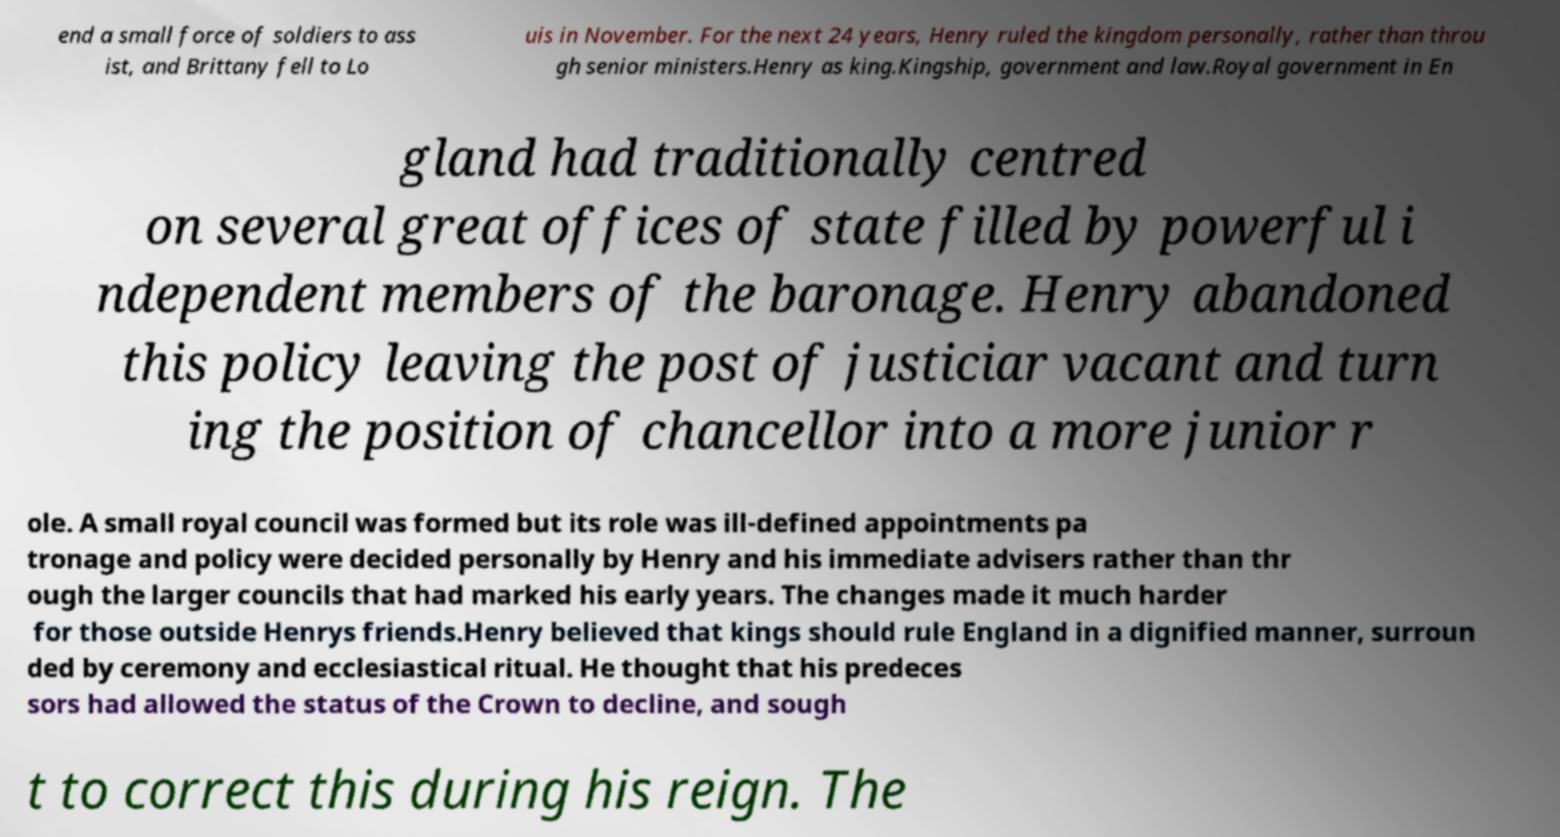Could you extract and type out the text from this image? end a small force of soldiers to ass ist, and Brittany fell to Lo uis in November. For the next 24 years, Henry ruled the kingdom personally, rather than throu gh senior ministers.Henry as king.Kingship, government and law.Royal government in En gland had traditionally centred on several great offices of state filled by powerful i ndependent members of the baronage. Henry abandoned this policy leaving the post of justiciar vacant and turn ing the position of chancellor into a more junior r ole. A small royal council was formed but its role was ill-defined appointments pa tronage and policy were decided personally by Henry and his immediate advisers rather than thr ough the larger councils that had marked his early years. The changes made it much harder for those outside Henrys friends.Henry believed that kings should rule England in a dignified manner, surroun ded by ceremony and ecclesiastical ritual. He thought that his predeces sors had allowed the status of the Crown to decline, and sough t to correct this during his reign. The 